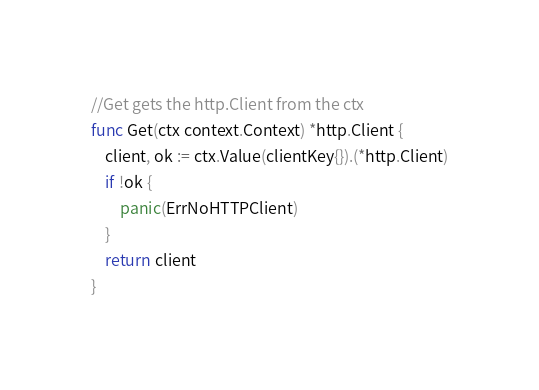<code> <loc_0><loc_0><loc_500><loc_500><_Go_>
//Get gets the http.Client from the ctx
func Get(ctx context.Context) *http.Client {
	client, ok := ctx.Value(clientKey{}).(*http.Client)
	if !ok {
		panic(ErrNoHTTPClient)
	}
	return client
}
</code> 